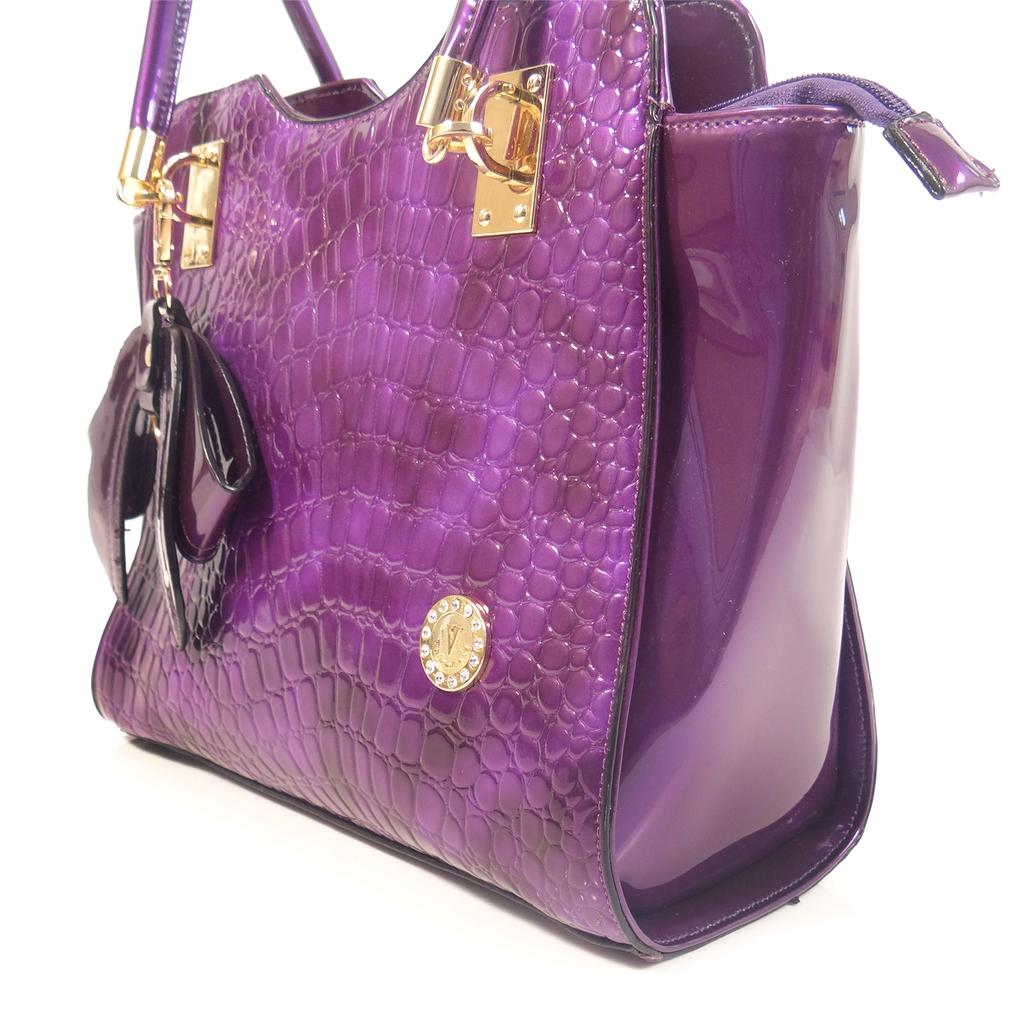What object can be seen in the image? There is a bag in the image. What type of field is visible in the background of the image? There is no field visible in the image; it only shows a bag. 